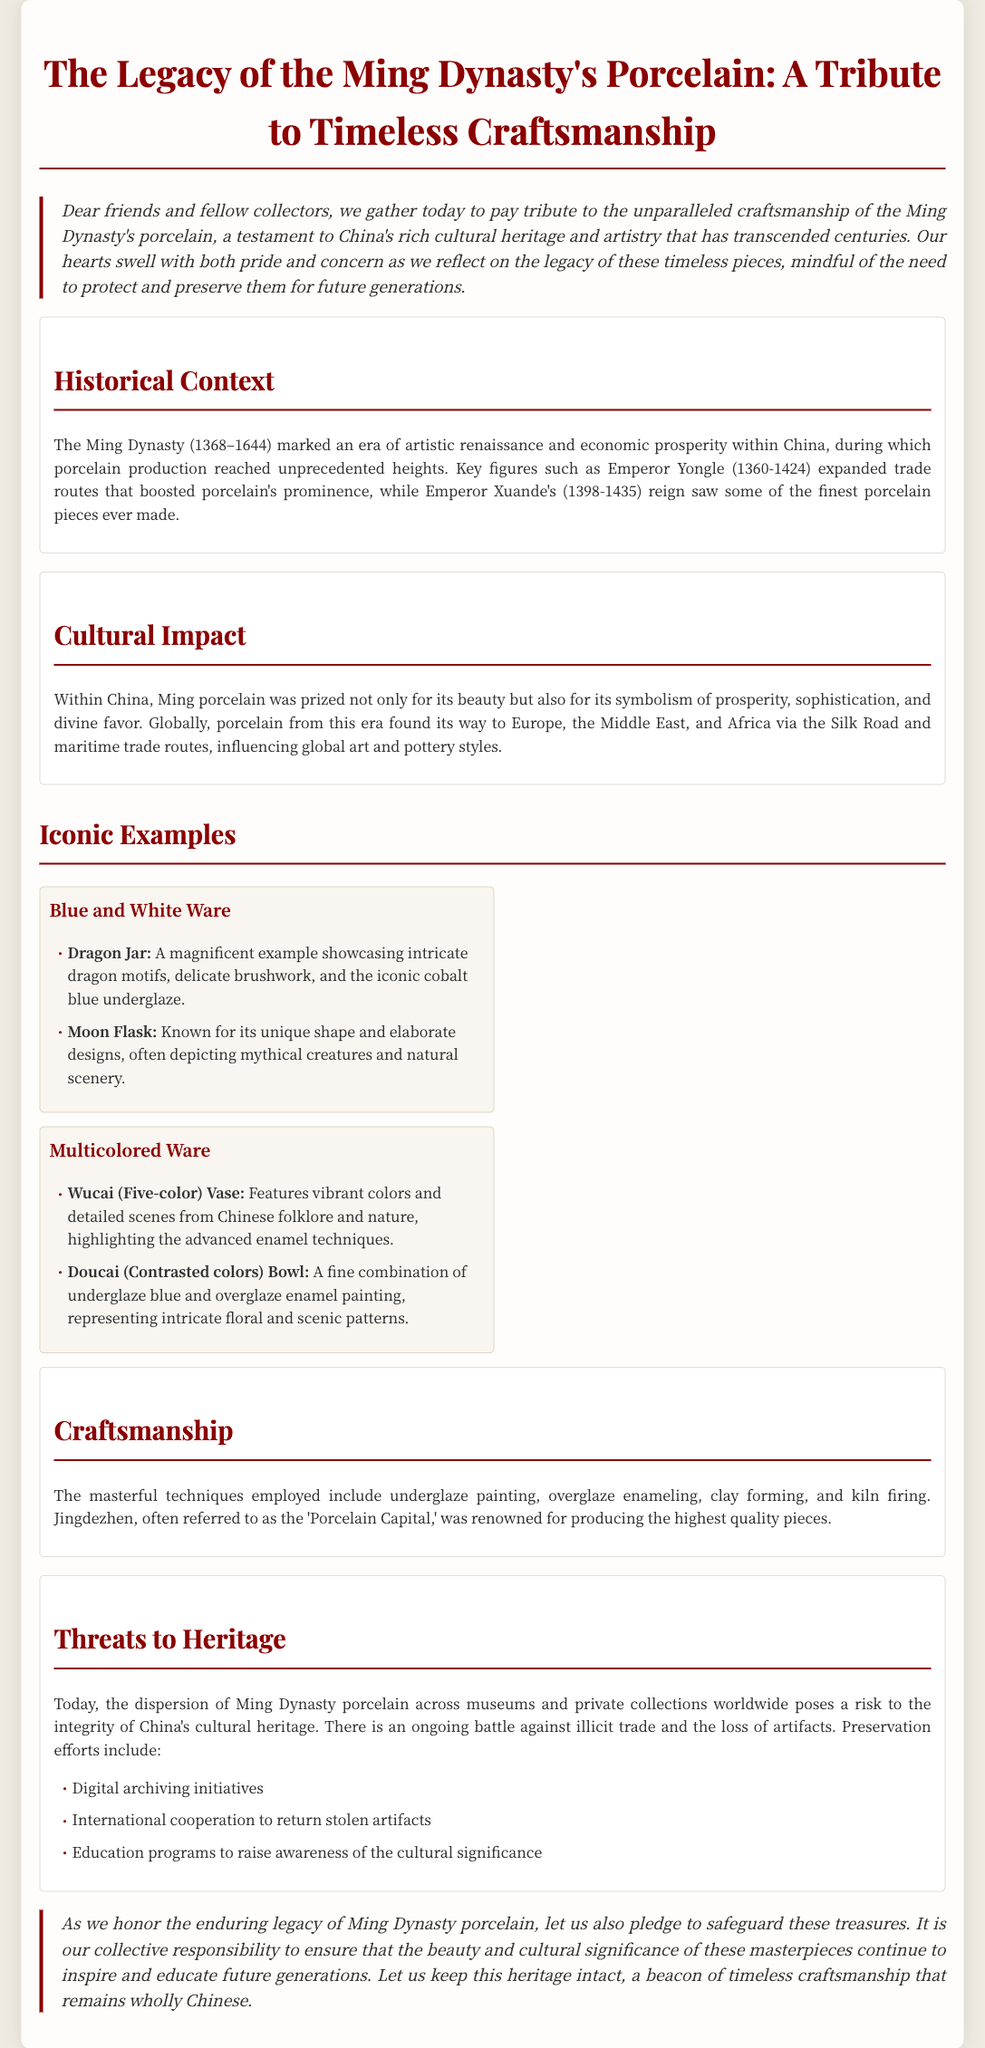What dynasty is the focus of this eulogy? The eulogy specifically honors the Ming Dynasty, as evidenced by the title and the content discussing its porcelain.
Answer: Ming Dynasty What period did the Ming Dynasty span? The document states that the Ming Dynasty lasted from 1368 to 1644, providing a clear timeframe for the period.
Answer: 1368–1644 Which significant emperor expanded trade routes during the Ming Dynasty? The text mentions Emperor Yongle as a key figure who played a crucial role in expanding trade routes for porcelain.
Answer: Emperor Yongle What are the two types of iconic porcelain mentioned? The document lists "Blue and White Ware" and "Multicolored Ware" as the two types of iconic porcelain from the Ming Dynasty.
Answer: Blue and White Ware, Multicolored Ware What city is referred to as the 'Porcelain Capital'? The eulogy mentions Jingdezhen as the city renowned for producing the highest quality porcelain during the Ming Dynasty.
Answer: Jingdezhen What is the primary threat to the heritage of Ming porcelain today? It is stated that the dispersion of Ming Dynasty porcelain across museums and private collections globally is a significant threat to cultural heritage.
Answer: Dispersion What preservation efforts are mentioned in the document? The eulogy lists digital archiving initiatives, international cooperation, and education programs as key preservation efforts.
Answer: Digital archiving initiatives, international cooperation, education programs What does the author urge the audience to do regarding Ming porcelain? The conclusion emphasizes the importance of safeguarding and preserving these treasures for future generations.
Answer: Safeguard and preserve How does the document describe the craftsmanship of Ming porcelain? The craftsmanship is described in terms of techniques such as underglaze painting and the reputation of a specific city for quality production.
Answer: Masterful techniques, Jingdezhen 